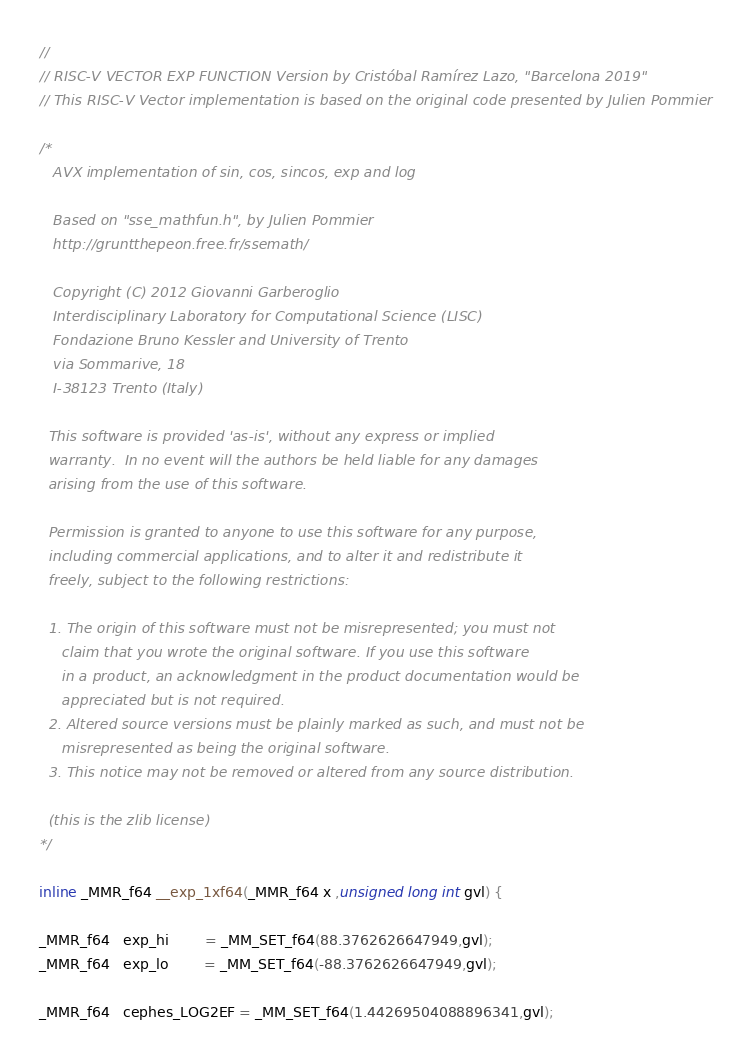Convert code to text. <code><loc_0><loc_0><loc_500><loc_500><_C_>// 
// RISC-V VECTOR EXP FUNCTION Version by Cristóbal Ramírez Lazo, "Barcelona 2019"
// This RISC-V Vector implementation is based on the original code presented by Julien Pommier

/* 
   AVX implementation of sin, cos, sincos, exp and log

   Based on "sse_mathfun.h", by Julien Pommier
   http://gruntthepeon.free.fr/ssemath/

   Copyright (C) 2012 Giovanni Garberoglio
   Interdisciplinary Laboratory for Computational Science (LISC)
   Fondazione Bruno Kessler and University of Trento
   via Sommarive, 18
   I-38123 Trento (Italy)

  This software is provided 'as-is', without any express or implied
  warranty.  In no event will the authors be held liable for any damages
  arising from the use of this software.

  Permission is granted to anyone to use this software for any purpose,
  including commercial applications, and to alter it and redistribute it
  freely, subject to the following restrictions:

  1. The origin of this software must not be misrepresented; you must not
     claim that you wrote the original software. If you use this software
     in a product, an acknowledgment in the product documentation would be
     appreciated but is not required.
  2. Altered source versions must be plainly marked as such, and must not be
     misrepresented as being the original software.
  3. This notice may not be removed or altered from any source distribution.

  (this is the zlib license)
*/

inline _MMR_f64 __exp_1xf64(_MMR_f64 x ,unsigned long int gvl) {

_MMR_f64   exp_hi        = _MM_SET_f64(88.3762626647949,gvl);
_MMR_f64   exp_lo        = _MM_SET_f64(-88.3762626647949,gvl);

_MMR_f64   cephes_LOG2EF = _MM_SET_f64(1.44269504088896341,gvl);</code> 